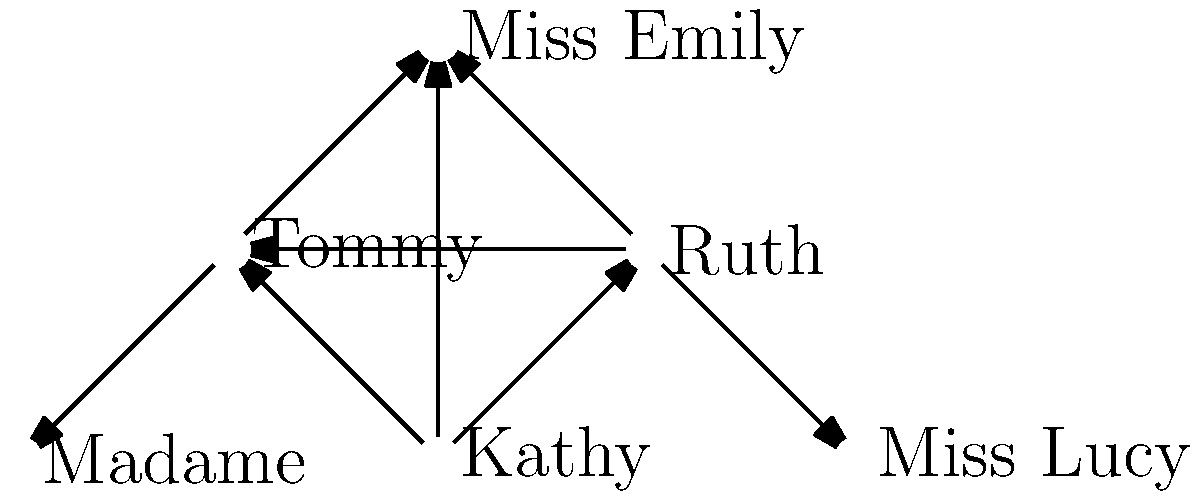In the network diagram representing character relationships in "Never Let Me Go," which character serves as the central node connecting the main characters to the authority figures at Hailsham? To answer this question, let's analyze the network diagram step-by-step:

1. Identify the main characters: Kathy, Ruth, and Tommy are positioned at the bottom of the diagram, forming a triangle. These are the protagonists of the story.

2. Identify the authority figures: Miss Emily, Madame, and Miss Lucy are positioned at the top and sides of the diagram. These are the adults in charge at Hailsham.

3. Look for connections: Notice that there are arrows connecting the main characters to each other, indicating their close relationships.

4. Find the central node: Observe that Miss Emily has arrows connecting her to Kathy, Ruth, and Tommy, as well as to Madame and Miss Lucy.

5. Analyze the role: Miss Emily's position in the diagram shows that she acts as a bridge between the main characters and the other authority figures.

6. Consider the context: In the novel, Miss Emily is the head guardian at Hailsham and plays a crucial role in the students' lives and their understanding of their purpose.

Based on this analysis, we can conclude that Miss Emily serves as the central node connecting the main characters to the authority figures at Hailsham.
Answer: Miss Emily 